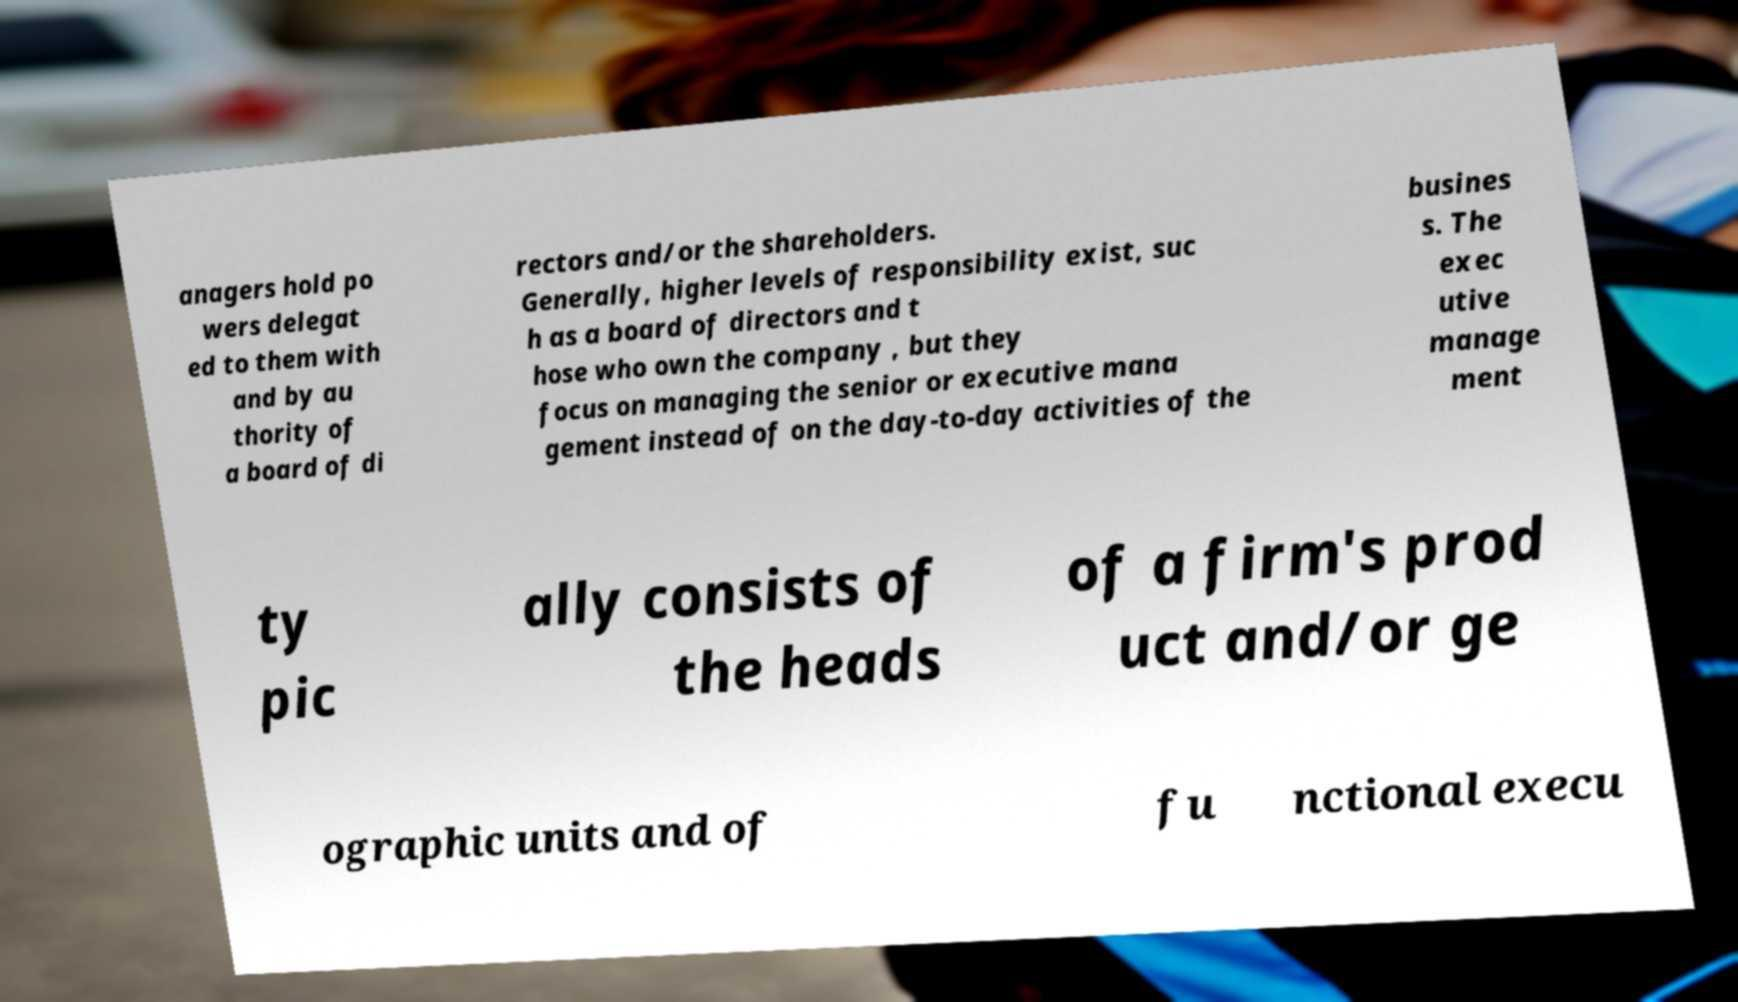Could you assist in decoding the text presented in this image and type it out clearly? anagers hold po wers delegat ed to them with and by au thority of a board of di rectors and/or the shareholders. Generally, higher levels of responsibility exist, suc h as a board of directors and t hose who own the company , but they focus on managing the senior or executive mana gement instead of on the day-to-day activities of the busines s. The exec utive manage ment ty pic ally consists of the heads of a firm's prod uct and/or ge ographic units and of fu nctional execu 